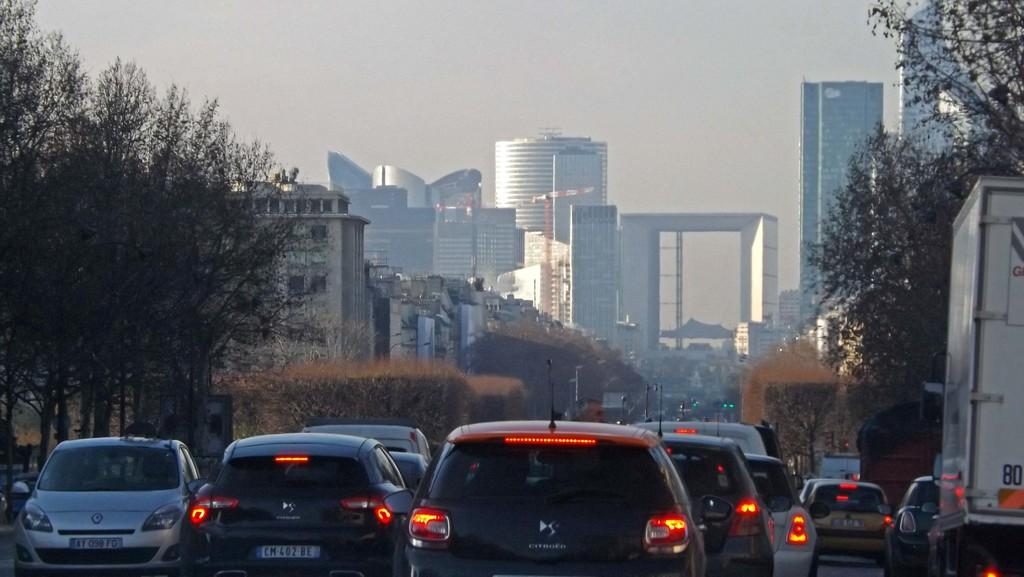What types of objects are present in the image? There are vehicles, trees, and poles in the image. What can be seen in the background of the image? There are buildings and the sky visible in the background of the image. Can you describe the environment in the image? The image features vehicles, trees, and poles, with buildings and the sky in the background. What is the size of the neck of the tree in the image? There is no mention of a tree's neck in the image, as trees do not have necks. 